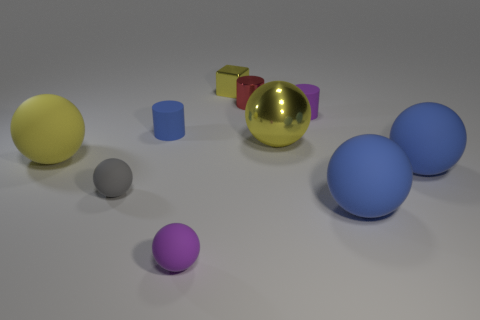What is the size of the red cylinder that is the same material as the yellow cube?
Ensure brevity in your answer.  Small. Are there any yellow metallic balls behind the blue rubber cylinder?
Your answer should be compact. No. There is another shiny thing that is the same shape as the tiny gray thing; what is its size?
Provide a short and direct response. Large. Does the small cube have the same color as the small cylinder that is left of the tiny metal block?
Ensure brevity in your answer.  No. Is the color of the small shiny cube the same as the large metal thing?
Give a very brief answer. Yes. Are there fewer purple rubber cylinders than blue things?
Your answer should be compact. Yes. How many other objects are the same color as the small block?
Provide a succinct answer. 2. What number of yellow spheres are there?
Ensure brevity in your answer.  2. Are there fewer tiny purple matte cylinders that are behind the metal block than large shiny cubes?
Provide a succinct answer. No. Does the yellow object that is to the right of the tiny red shiny cylinder have the same material as the red object?
Provide a succinct answer. Yes. 